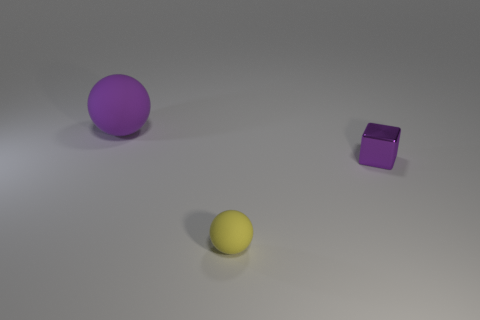Can you describe the texture of the objects visible in the image? Certainly! The image features a collection of objects with varying textures. The yellow ball in the foreground has a rubbery texture, indicating it's likely smooth with a somewhat matte finish. The purple sphere seems to have a similar matte surface, albeit without the rubbery appearance. Lastly, the purple cube possesses a reflective surface that seems almost glass-like, setting it apart from the spherical objects in the scene.  How would you interpret the spacing between the objects? The objects are spaced out across the image, each maintaining a notable distance from the others. This arrangement could symbolize isolation or independence. Alternatively, it might simply reflect a random placement without any deeper meaning. In terms of composition, the spaces create a balance in the image, with no one area appearing too crowded or empty. 